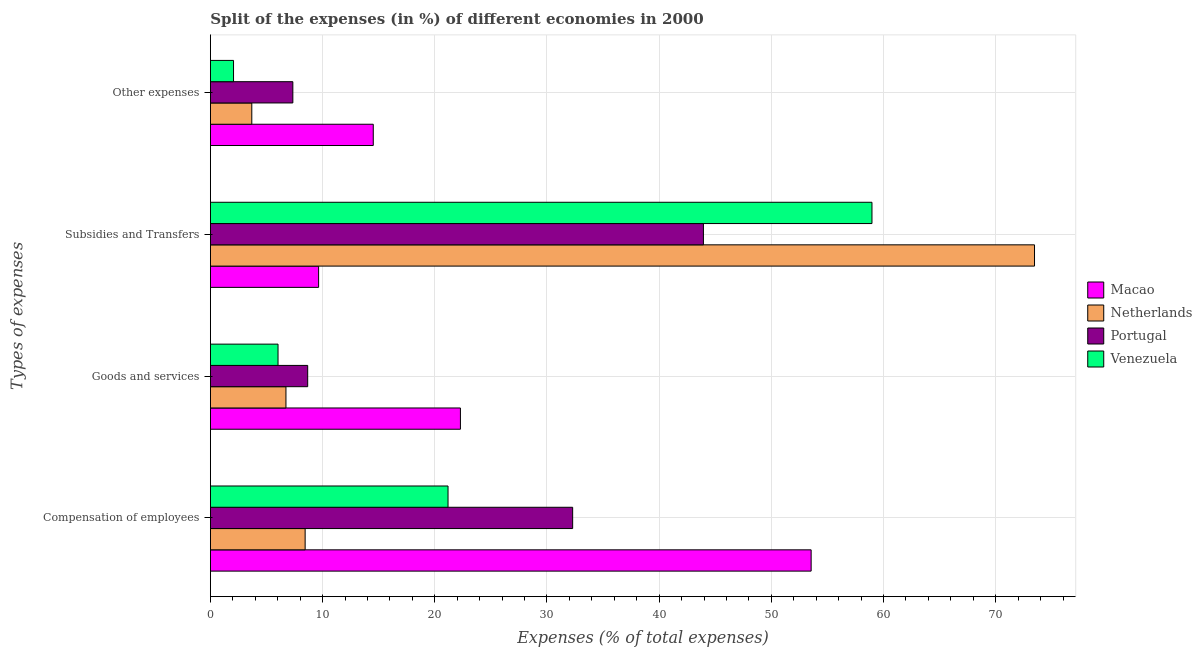How many different coloured bars are there?
Provide a succinct answer. 4. How many bars are there on the 1st tick from the bottom?
Offer a terse response. 4. What is the label of the 2nd group of bars from the top?
Make the answer very short. Subsidies and Transfers. What is the percentage of amount spent on other expenses in Macao?
Your answer should be very brief. 14.52. Across all countries, what is the maximum percentage of amount spent on other expenses?
Ensure brevity in your answer.  14.52. Across all countries, what is the minimum percentage of amount spent on goods and services?
Your response must be concise. 6.03. In which country was the percentage of amount spent on other expenses maximum?
Your answer should be very brief. Macao. In which country was the percentage of amount spent on subsidies minimum?
Ensure brevity in your answer.  Macao. What is the total percentage of amount spent on compensation of employees in the graph?
Make the answer very short. 115.47. What is the difference between the percentage of amount spent on goods and services in Macao and that in Portugal?
Provide a succinct answer. 13.61. What is the difference between the percentage of amount spent on goods and services in Macao and the percentage of amount spent on subsidies in Netherlands?
Offer a terse response. -51.17. What is the average percentage of amount spent on compensation of employees per country?
Keep it short and to the point. 28.87. What is the difference between the percentage of amount spent on other expenses and percentage of amount spent on goods and services in Portugal?
Your answer should be very brief. -1.32. In how many countries, is the percentage of amount spent on compensation of employees greater than 68 %?
Make the answer very short. 0. What is the ratio of the percentage of amount spent on goods and services in Portugal to that in Macao?
Your response must be concise. 0.39. Is the percentage of amount spent on goods and services in Macao less than that in Portugal?
Offer a terse response. No. What is the difference between the highest and the second highest percentage of amount spent on subsidies?
Your answer should be compact. 14.49. What is the difference between the highest and the lowest percentage of amount spent on other expenses?
Offer a terse response. 12.45. In how many countries, is the percentage of amount spent on goods and services greater than the average percentage of amount spent on goods and services taken over all countries?
Your answer should be very brief. 1. Is the sum of the percentage of amount spent on compensation of employees in Portugal and Venezuela greater than the maximum percentage of amount spent on goods and services across all countries?
Ensure brevity in your answer.  Yes. Is it the case that in every country, the sum of the percentage of amount spent on subsidies and percentage of amount spent on compensation of employees is greater than the sum of percentage of amount spent on other expenses and percentage of amount spent on goods and services?
Your response must be concise. Yes. How many bars are there?
Your response must be concise. 16. Are all the bars in the graph horizontal?
Your answer should be very brief. Yes. What is the difference between two consecutive major ticks on the X-axis?
Provide a succinct answer. 10. Are the values on the major ticks of X-axis written in scientific E-notation?
Offer a terse response. No. Does the graph contain any zero values?
Make the answer very short. No. Where does the legend appear in the graph?
Provide a short and direct response. Center right. What is the title of the graph?
Provide a succinct answer. Split of the expenses (in %) of different economies in 2000. Does "Channel Islands" appear as one of the legend labels in the graph?
Your answer should be compact. No. What is the label or title of the X-axis?
Your response must be concise. Expenses (% of total expenses). What is the label or title of the Y-axis?
Give a very brief answer. Types of expenses. What is the Expenses (% of total expenses) in Macao in Compensation of employees?
Provide a succinct answer. 53.55. What is the Expenses (% of total expenses) of Netherlands in Compensation of employees?
Offer a terse response. 8.45. What is the Expenses (% of total expenses) of Portugal in Compensation of employees?
Your answer should be compact. 32.29. What is the Expenses (% of total expenses) in Venezuela in Compensation of employees?
Offer a terse response. 21.18. What is the Expenses (% of total expenses) of Macao in Goods and services?
Your answer should be very brief. 22.29. What is the Expenses (% of total expenses) in Netherlands in Goods and services?
Offer a very short reply. 6.74. What is the Expenses (% of total expenses) in Portugal in Goods and services?
Provide a short and direct response. 8.67. What is the Expenses (% of total expenses) in Venezuela in Goods and services?
Provide a short and direct response. 6.03. What is the Expenses (% of total expenses) of Macao in Subsidies and Transfers?
Your answer should be compact. 9.65. What is the Expenses (% of total expenses) in Netherlands in Subsidies and Transfers?
Offer a terse response. 73.46. What is the Expenses (% of total expenses) in Portugal in Subsidies and Transfers?
Ensure brevity in your answer.  43.95. What is the Expenses (% of total expenses) of Venezuela in Subsidies and Transfers?
Your response must be concise. 58.97. What is the Expenses (% of total expenses) of Macao in Other expenses?
Keep it short and to the point. 14.52. What is the Expenses (% of total expenses) in Netherlands in Other expenses?
Provide a short and direct response. 3.69. What is the Expenses (% of total expenses) of Portugal in Other expenses?
Your response must be concise. 7.35. What is the Expenses (% of total expenses) of Venezuela in Other expenses?
Make the answer very short. 2.06. Across all Types of expenses, what is the maximum Expenses (% of total expenses) in Macao?
Offer a terse response. 53.55. Across all Types of expenses, what is the maximum Expenses (% of total expenses) of Netherlands?
Provide a succinct answer. 73.46. Across all Types of expenses, what is the maximum Expenses (% of total expenses) of Portugal?
Ensure brevity in your answer.  43.95. Across all Types of expenses, what is the maximum Expenses (% of total expenses) in Venezuela?
Make the answer very short. 58.97. Across all Types of expenses, what is the minimum Expenses (% of total expenses) of Macao?
Your response must be concise. 9.65. Across all Types of expenses, what is the minimum Expenses (% of total expenses) of Netherlands?
Ensure brevity in your answer.  3.69. Across all Types of expenses, what is the minimum Expenses (% of total expenses) of Portugal?
Offer a terse response. 7.35. Across all Types of expenses, what is the minimum Expenses (% of total expenses) of Venezuela?
Ensure brevity in your answer.  2.06. What is the total Expenses (% of total expenses) in Netherlands in the graph?
Ensure brevity in your answer.  92.33. What is the total Expenses (% of total expenses) of Portugal in the graph?
Offer a terse response. 92.26. What is the total Expenses (% of total expenses) in Venezuela in the graph?
Provide a short and direct response. 88.25. What is the difference between the Expenses (% of total expenses) in Macao in Compensation of employees and that in Goods and services?
Offer a very short reply. 31.26. What is the difference between the Expenses (% of total expenses) in Netherlands in Compensation of employees and that in Goods and services?
Give a very brief answer. 1.71. What is the difference between the Expenses (% of total expenses) of Portugal in Compensation of employees and that in Goods and services?
Provide a succinct answer. 23.62. What is the difference between the Expenses (% of total expenses) in Venezuela in Compensation of employees and that in Goods and services?
Give a very brief answer. 15.15. What is the difference between the Expenses (% of total expenses) in Macao in Compensation of employees and that in Subsidies and Transfers?
Make the answer very short. 43.9. What is the difference between the Expenses (% of total expenses) of Netherlands in Compensation of employees and that in Subsidies and Transfers?
Ensure brevity in your answer.  -65.01. What is the difference between the Expenses (% of total expenses) in Portugal in Compensation of employees and that in Subsidies and Transfers?
Give a very brief answer. -11.66. What is the difference between the Expenses (% of total expenses) in Venezuela in Compensation of employees and that in Subsidies and Transfers?
Make the answer very short. -37.79. What is the difference between the Expenses (% of total expenses) of Macao in Compensation of employees and that in Other expenses?
Give a very brief answer. 39.03. What is the difference between the Expenses (% of total expenses) in Netherlands in Compensation of employees and that in Other expenses?
Make the answer very short. 4.76. What is the difference between the Expenses (% of total expenses) of Portugal in Compensation of employees and that in Other expenses?
Ensure brevity in your answer.  24.94. What is the difference between the Expenses (% of total expenses) in Venezuela in Compensation of employees and that in Other expenses?
Provide a succinct answer. 19.12. What is the difference between the Expenses (% of total expenses) in Macao in Goods and services and that in Subsidies and Transfers?
Your response must be concise. 12.64. What is the difference between the Expenses (% of total expenses) of Netherlands in Goods and services and that in Subsidies and Transfers?
Your answer should be compact. -66.72. What is the difference between the Expenses (% of total expenses) in Portugal in Goods and services and that in Subsidies and Transfers?
Ensure brevity in your answer.  -35.27. What is the difference between the Expenses (% of total expenses) in Venezuela in Goods and services and that in Subsidies and Transfers?
Keep it short and to the point. -52.94. What is the difference between the Expenses (% of total expenses) in Macao in Goods and services and that in Other expenses?
Your response must be concise. 7.77. What is the difference between the Expenses (% of total expenses) in Netherlands in Goods and services and that in Other expenses?
Your response must be concise. 3.05. What is the difference between the Expenses (% of total expenses) of Portugal in Goods and services and that in Other expenses?
Ensure brevity in your answer.  1.32. What is the difference between the Expenses (% of total expenses) in Venezuela in Goods and services and that in Other expenses?
Ensure brevity in your answer.  3.97. What is the difference between the Expenses (% of total expenses) in Macao in Subsidies and Transfers and that in Other expenses?
Ensure brevity in your answer.  -4.87. What is the difference between the Expenses (% of total expenses) of Netherlands in Subsidies and Transfers and that in Other expenses?
Provide a succinct answer. 69.77. What is the difference between the Expenses (% of total expenses) in Portugal in Subsidies and Transfers and that in Other expenses?
Give a very brief answer. 36.6. What is the difference between the Expenses (% of total expenses) in Venezuela in Subsidies and Transfers and that in Other expenses?
Offer a very short reply. 56.91. What is the difference between the Expenses (% of total expenses) in Macao in Compensation of employees and the Expenses (% of total expenses) in Netherlands in Goods and services?
Provide a short and direct response. 46.81. What is the difference between the Expenses (% of total expenses) in Macao in Compensation of employees and the Expenses (% of total expenses) in Portugal in Goods and services?
Ensure brevity in your answer.  44.87. What is the difference between the Expenses (% of total expenses) of Macao in Compensation of employees and the Expenses (% of total expenses) of Venezuela in Goods and services?
Offer a very short reply. 47.52. What is the difference between the Expenses (% of total expenses) of Netherlands in Compensation of employees and the Expenses (% of total expenses) of Portugal in Goods and services?
Provide a succinct answer. -0.23. What is the difference between the Expenses (% of total expenses) of Netherlands in Compensation of employees and the Expenses (% of total expenses) of Venezuela in Goods and services?
Your answer should be very brief. 2.42. What is the difference between the Expenses (% of total expenses) in Portugal in Compensation of employees and the Expenses (% of total expenses) in Venezuela in Goods and services?
Provide a short and direct response. 26.26. What is the difference between the Expenses (% of total expenses) in Macao in Compensation of employees and the Expenses (% of total expenses) in Netherlands in Subsidies and Transfers?
Provide a succinct answer. -19.91. What is the difference between the Expenses (% of total expenses) in Macao in Compensation of employees and the Expenses (% of total expenses) in Portugal in Subsidies and Transfers?
Make the answer very short. 9.6. What is the difference between the Expenses (% of total expenses) in Macao in Compensation of employees and the Expenses (% of total expenses) in Venezuela in Subsidies and Transfers?
Your answer should be very brief. -5.42. What is the difference between the Expenses (% of total expenses) in Netherlands in Compensation of employees and the Expenses (% of total expenses) in Portugal in Subsidies and Transfers?
Provide a succinct answer. -35.5. What is the difference between the Expenses (% of total expenses) of Netherlands in Compensation of employees and the Expenses (% of total expenses) of Venezuela in Subsidies and Transfers?
Provide a short and direct response. -50.52. What is the difference between the Expenses (% of total expenses) in Portugal in Compensation of employees and the Expenses (% of total expenses) in Venezuela in Subsidies and Transfers?
Provide a succinct answer. -26.68. What is the difference between the Expenses (% of total expenses) in Macao in Compensation of employees and the Expenses (% of total expenses) in Netherlands in Other expenses?
Offer a terse response. 49.86. What is the difference between the Expenses (% of total expenses) in Macao in Compensation of employees and the Expenses (% of total expenses) in Portugal in Other expenses?
Your answer should be compact. 46.2. What is the difference between the Expenses (% of total expenses) of Macao in Compensation of employees and the Expenses (% of total expenses) of Venezuela in Other expenses?
Offer a terse response. 51.48. What is the difference between the Expenses (% of total expenses) in Netherlands in Compensation of employees and the Expenses (% of total expenses) in Portugal in Other expenses?
Offer a very short reply. 1.1. What is the difference between the Expenses (% of total expenses) of Netherlands in Compensation of employees and the Expenses (% of total expenses) of Venezuela in Other expenses?
Keep it short and to the point. 6.38. What is the difference between the Expenses (% of total expenses) in Portugal in Compensation of employees and the Expenses (% of total expenses) in Venezuela in Other expenses?
Give a very brief answer. 30.23. What is the difference between the Expenses (% of total expenses) in Macao in Goods and services and the Expenses (% of total expenses) in Netherlands in Subsidies and Transfers?
Your response must be concise. -51.17. What is the difference between the Expenses (% of total expenses) of Macao in Goods and services and the Expenses (% of total expenses) of Portugal in Subsidies and Transfers?
Keep it short and to the point. -21.66. What is the difference between the Expenses (% of total expenses) in Macao in Goods and services and the Expenses (% of total expenses) in Venezuela in Subsidies and Transfers?
Your answer should be very brief. -36.68. What is the difference between the Expenses (% of total expenses) in Netherlands in Goods and services and the Expenses (% of total expenses) in Portugal in Subsidies and Transfers?
Your response must be concise. -37.21. What is the difference between the Expenses (% of total expenses) in Netherlands in Goods and services and the Expenses (% of total expenses) in Venezuela in Subsidies and Transfers?
Provide a succinct answer. -52.23. What is the difference between the Expenses (% of total expenses) of Portugal in Goods and services and the Expenses (% of total expenses) of Venezuela in Subsidies and Transfers?
Ensure brevity in your answer.  -50.3. What is the difference between the Expenses (% of total expenses) of Macao in Goods and services and the Expenses (% of total expenses) of Netherlands in Other expenses?
Your answer should be very brief. 18.6. What is the difference between the Expenses (% of total expenses) in Macao in Goods and services and the Expenses (% of total expenses) in Portugal in Other expenses?
Provide a short and direct response. 14.94. What is the difference between the Expenses (% of total expenses) in Macao in Goods and services and the Expenses (% of total expenses) in Venezuela in Other expenses?
Provide a succinct answer. 20.22. What is the difference between the Expenses (% of total expenses) in Netherlands in Goods and services and the Expenses (% of total expenses) in Portugal in Other expenses?
Keep it short and to the point. -0.61. What is the difference between the Expenses (% of total expenses) in Netherlands in Goods and services and the Expenses (% of total expenses) in Venezuela in Other expenses?
Make the answer very short. 4.67. What is the difference between the Expenses (% of total expenses) in Portugal in Goods and services and the Expenses (% of total expenses) in Venezuela in Other expenses?
Ensure brevity in your answer.  6.61. What is the difference between the Expenses (% of total expenses) in Macao in Subsidies and Transfers and the Expenses (% of total expenses) in Netherlands in Other expenses?
Provide a short and direct response. 5.96. What is the difference between the Expenses (% of total expenses) in Macao in Subsidies and Transfers and the Expenses (% of total expenses) in Portugal in Other expenses?
Your response must be concise. 2.3. What is the difference between the Expenses (% of total expenses) of Macao in Subsidies and Transfers and the Expenses (% of total expenses) of Venezuela in Other expenses?
Your response must be concise. 7.58. What is the difference between the Expenses (% of total expenses) of Netherlands in Subsidies and Transfers and the Expenses (% of total expenses) of Portugal in Other expenses?
Offer a very short reply. 66.11. What is the difference between the Expenses (% of total expenses) of Netherlands in Subsidies and Transfers and the Expenses (% of total expenses) of Venezuela in Other expenses?
Offer a terse response. 71.39. What is the difference between the Expenses (% of total expenses) of Portugal in Subsidies and Transfers and the Expenses (% of total expenses) of Venezuela in Other expenses?
Offer a terse response. 41.88. What is the average Expenses (% of total expenses) of Macao per Types of expenses?
Your answer should be compact. 25. What is the average Expenses (% of total expenses) of Netherlands per Types of expenses?
Your response must be concise. 23.08. What is the average Expenses (% of total expenses) of Portugal per Types of expenses?
Your response must be concise. 23.07. What is the average Expenses (% of total expenses) in Venezuela per Types of expenses?
Ensure brevity in your answer.  22.06. What is the difference between the Expenses (% of total expenses) in Macao and Expenses (% of total expenses) in Netherlands in Compensation of employees?
Your response must be concise. 45.1. What is the difference between the Expenses (% of total expenses) in Macao and Expenses (% of total expenses) in Portugal in Compensation of employees?
Give a very brief answer. 21.26. What is the difference between the Expenses (% of total expenses) of Macao and Expenses (% of total expenses) of Venezuela in Compensation of employees?
Provide a succinct answer. 32.37. What is the difference between the Expenses (% of total expenses) of Netherlands and Expenses (% of total expenses) of Portugal in Compensation of employees?
Provide a short and direct response. -23.85. What is the difference between the Expenses (% of total expenses) of Netherlands and Expenses (% of total expenses) of Venezuela in Compensation of employees?
Provide a succinct answer. -12.74. What is the difference between the Expenses (% of total expenses) in Portugal and Expenses (% of total expenses) in Venezuela in Compensation of employees?
Your response must be concise. 11.11. What is the difference between the Expenses (% of total expenses) in Macao and Expenses (% of total expenses) in Netherlands in Goods and services?
Your response must be concise. 15.55. What is the difference between the Expenses (% of total expenses) in Macao and Expenses (% of total expenses) in Portugal in Goods and services?
Keep it short and to the point. 13.61. What is the difference between the Expenses (% of total expenses) of Macao and Expenses (% of total expenses) of Venezuela in Goods and services?
Your response must be concise. 16.26. What is the difference between the Expenses (% of total expenses) in Netherlands and Expenses (% of total expenses) in Portugal in Goods and services?
Your answer should be very brief. -1.94. What is the difference between the Expenses (% of total expenses) in Netherlands and Expenses (% of total expenses) in Venezuela in Goods and services?
Ensure brevity in your answer.  0.71. What is the difference between the Expenses (% of total expenses) of Portugal and Expenses (% of total expenses) of Venezuela in Goods and services?
Give a very brief answer. 2.64. What is the difference between the Expenses (% of total expenses) in Macao and Expenses (% of total expenses) in Netherlands in Subsidies and Transfers?
Give a very brief answer. -63.81. What is the difference between the Expenses (% of total expenses) in Macao and Expenses (% of total expenses) in Portugal in Subsidies and Transfers?
Your response must be concise. -34.3. What is the difference between the Expenses (% of total expenses) of Macao and Expenses (% of total expenses) of Venezuela in Subsidies and Transfers?
Provide a succinct answer. -49.32. What is the difference between the Expenses (% of total expenses) in Netherlands and Expenses (% of total expenses) in Portugal in Subsidies and Transfers?
Provide a short and direct response. 29.51. What is the difference between the Expenses (% of total expenses) in Netherlands and Expenses (% of total expenses) in Venezuela in Subsidies and Transfers?
Your response must be concise. 14.49. What is the difference between the Expenses (% of total expenses) of Portugal and Expenses (% of total expenses) of Venezuela in Subsidies and Transfers?
Your response must be concise. -15.02. What is the difference between the Expenses (% of total expenses) in Macao and Expenses (% of total expenses) in Netherlands in Other expenses?
Offer a very short reply. 10.83. What is the difference between the Expenses (% of total expenses) of Macao and Expenses (% of total expenses) of Portugal in Other expenses?
Ensure brevity in your answer.  7.17. What is the difference between the Expenses (% of total expenses) in Macao and Expenses (% of total expenses) in Venezuela in Other expenses?
Give a very brief answer. 12.45. What is the difference between the Expenses (% of total expenses) of Netherlands and Expenses (% of total expenses) of Portugal in Other expenses?
Provide a short and direct response. -3.66. What is the difference between the Expenses (% of total expenses) of Netherlands and Expenses (% of total expenses) of Venezuela in Other expenses?
Provide a short and direct response. 1.63. What is the difference between the Expenses (% of total expenses) in Portugal and Expenses (% of total expenses) in Venezuela in Other expenses?
Your answer should be compact. 5.29. What is the ratio of the Expenses (% of total expenses) in Macao in Compensation of employees to that in Goods and services?
Your response must be concise. 2.4. What is the ratio of the Expenses (% of total expenses) in Netherlands in Compensation of employees to that in Goods and services?
Offer a terse response. 1.25. What is the ratio of the Expenses (% of total expenses) of Portugal in Compensation of employees to that in Goods and services?
Offer a very short reply. 3.72. What is the ratio of the Expenses (% of total expenses) in Venezuela in Compensation of employees to that in Goods and services?
Offer a terse response. 3.51. What is the ratio of the Expenses (% of total expenses) in Macao in Compensation of employees to that in Subsidies and Transfers?
Your answer should be compact. 5.55. What is the ratio of the Expenses (% of total expenses) of Netherlands in Compensation of employees to that in Subsidies and Transfers?
Keep it short and to the point. 0.12. What is the ratio of the Expenses (% of total expenses) in Portugal in Compensation of employees to that in Subsidies and Transfers?
Offer a terse response. 0.73. What is the ratio of the Expenses (% of total expenses) in Venezuela in Compensation of employees to that in Subsidies and Transfers?
Your response must be concise. 0.36. What is the ratio of the Expenses (% of total expenses) of Macao in Compensation of employees to that in Other expenses?
Provide a short and direct response. 3.69. What is the ratio of the Expenses (% of total expenses) of Netherlands in Compensation of employees to that in Other expenses?
Your answer should be compact. 2.29. What is the ratio of the Expenses (% of total expenses) of Portugal in Compensation of employees to that in Other expenses?
Make the answer very short. 4.39. What is the ratio of the Expenses (% of total expenses) in Venezuela in Compensation of employees to that in Other expenses?
Ensure brevity in your answer.  10.26. What is the ratio of the Expenses (% of total expenses) in Macao in Goods and services to that in Subsidies and Transfers?
Ensure brevity in your answer.  2.31. What is the ratio of the Expenses (% of total expenses) of Netherlands in Goods and services to that in Subsidies and Transfers?
Offer a terse response. 0.09. What is the ratio of the Expenses (% of total expenses) in Portugal in Goods and services to that in Subsidies and Transfers?
Your answer should be very brief. 0.2. What is the ratio of the Expenses (% of total expenses) in Venezuela in Goods and services to that in Subsidies and Transfers?
Provide a short and direct response. 0.1. What is the ratio of the Expenses (% of total expenses) in Macao in Goods and services to that in Other expenses?
Your answer should be compact. 1.54. What is the ratio of the Expenses (% of total expenses) of Netherlands in Goods and services to that in Other expenses?
Your response must be concise. 1.83. What is the ratio of the Expenses (% of total expenses) in Portugal in Goods and services to that in Other expenses?
Offer a terse response. 1.18. What is the ratio of the Expenses (% of total expenses) in Venezuela in Goods and services to that in Other expenses?
Offer a very short reply. 2.92. What is the ratio of the Expenses (% of total expenses) in Macao in Subsidies and Transfers to that in Other expenses?
Offer a very short reply. 0.66. What is the ratio of the Expenses (% of total expenses) of Netherlands in Subsidies and Transfers to that in Other expenses?
Provide a succinct answer. 19.9. What is the ratio of the Expenses (% of total expenses) of Portugal in Subsidies and Transfers to that in Other expenses?
Provide a succinct answer. 5.98. What is the ratio of the Expenses (% of total expenses) in Venezuela in Subsidies and Transfers to that in Other expenses?
Make the answer very short. 28.58. What is the difference between the highest and the second highest Expenses (% of total expenses) of Macao?
Provide a succinct answer. 31.26. What is the difference between the highest and the second highest Expenses (% of total expenses) of Netherlands?
Your response must be concise. 65.01. What is the difference between the highest and the second highest Expenses (% of total expenses) of Portugal?
Your response must be concise. 11.66. What is the difference between the highest and the second highest Expenses (% of total expenses) in Venezuela?
Your response must be concise. 37.79. What is the difference between the highest and the lowest Expenses (% of total expenses) in Macao?
Give a very brief answer. 43.9. What is the difference between the highest and the lowest Expenses (% of total expenses) in Netherlands?
Ensure brevity in your answer.  69.77. What is the difference between the highest and the lowest Expenses (% of total expenses) of Portugal?
Your answer should be very brief. 36.6. What is the difference between the highest and the lowest Expenses (% of total expenses) in Venezuela?
Your answer should be compact. 56.91. 